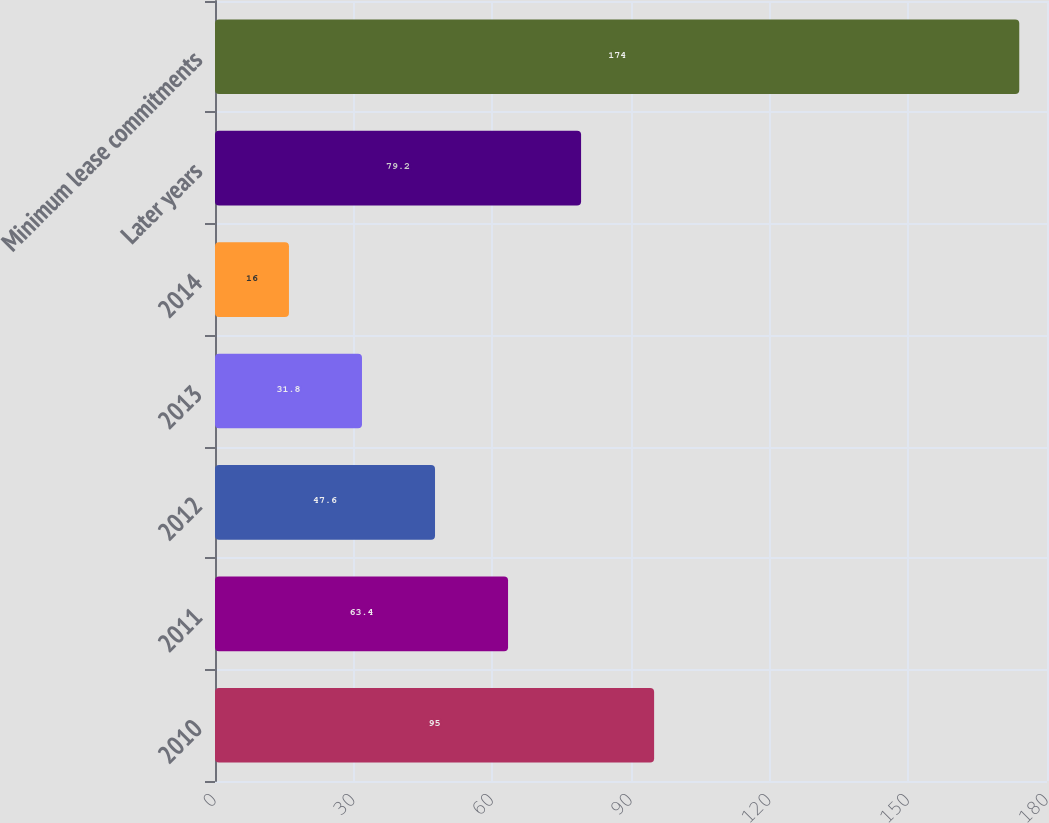Convert chart to OTSL. <chart><loc_0><loc_0><loc_500><loc_500><bar_chart><fcel>2010<fcel>2011<fcel>2012<fcel>2013<fcel>2014<fcel>Later years<fcel>Minimum lease commitments<nl><fcel>95<fcel>63.4<fcel>47.6<fcel>31.8<fcel>16<fcel>79.2<fcel>174<nl></chart> 